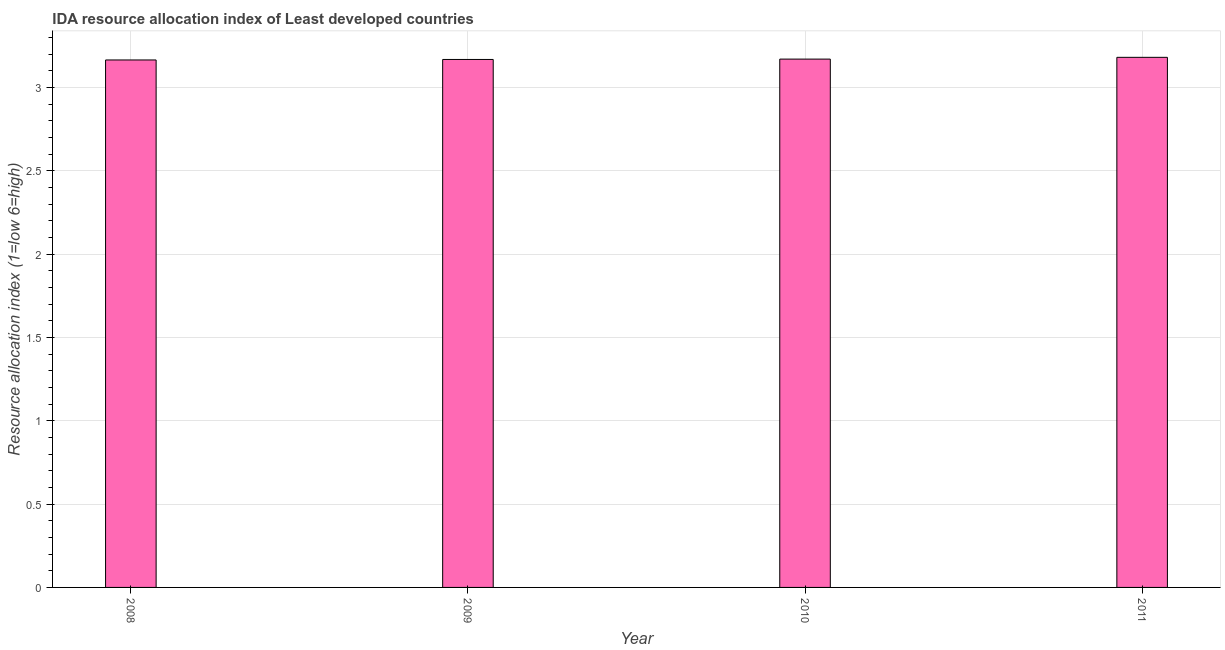What is the title of the graph?
Provide a short and direct response. IDA resource allocation index of Least developed countries. What is the label or title of the X-axis?
Give a very brief answer. Year. What is the label or title of the Y-axis?
Provide a short and direct response. Resource allocation index (1=low 6=high). What is the ida resource allocation index in 2009?
Your answer should be very brief. 3.17. Across all years, what is the maximum ida resource allocation index?
Your answer should be very brief. 3.18. Across all years, what is the minimum ida resource allocation index?
Your answer should be compact. 3.16. In which year was the ida resource allocation index maximum?
Make the answer very short. 2011. In which year was the ida resource allocation index minimum?
Give a very brief answer. 2008. What is the sum of the ida resource allocation index?
Offer a terse response. 12.68. What is the difference between the ida resource allocation index in 2008 and 2010?
Your response must be concise. -0.01. What is the average ida resource allocation index per year?
Provide a succinct answer. 3.17. What is the median ida resource allocation index?
Provide a short and direct response. 3.17. Do a majority of the years between 2008 and 2009 (inclusive) have ida resource allocation index greater than 1.6 ?
Offer a very short reply. Yes. What is the ratio of the ida resource allocation index in 2010 to that in 2011?
Your answer should be compact. 1. Is the ida resource allocation index in 2010 less than that in 2011?
Provide a succinct answer. Yes. Is the difference between the ida resource allocation index in 2009 and 2011 greater than the difference between any two years?
Make the answer very short. No. What is the difference between the highest and the second highest ida resource allocation index?
Ensure brevity in your answer.  0.01. Is the sum of the ida resource allocation index in 2009 and 2010 greater than the maximum ida resource allocation index across all years?
Provide a succinct answer. Yes. What is the difference between the highest and the lowest ida resource allocation index?
Your answer should be very brief. 0.02. In how many years, is the ida resource allocation index greater than the average ida resource allocation index taken over all years?
Your answer should be very brief. 1. Are all the bars in the graph horizontal?
Your answer should be very brief. No. What is the difference between two consecutive major ticks on the Y-axis?
Offer a terse response. 0.5. What is the Resource allocation index (1=low 6=high) in 2008?
Keep it short and to the point. 3.16. What is the Resource allocation index (1=low 6=high) in 2009?
Offer a terse response. 3.17. What is the Resource allocation index (1=low 6=high) in 2010?
Provide a short and direct response. 3.17. What is the Resource allocation index (1=low 6=high) of 2011?
Give a very brief answer. 3.18. What is the difference between the Resource allocation index (1=low 6=high) in 2008 and 2009?
Offer a terse response. -0. What is the difference between the Resource allocation index (1=low 6=high) in 2008 and 2010?
Your answer should be very brief. -0.01. What is the difference between the Resource allocation index (1=low 6=high) in 2008 and 2011?
Your answer should be very brief. -0.02. What is the difference between the Resource allocation index (1=low 6=high) in 2009 and 2010?
Give a very brief answer. -0. What is the difference between the Resource allocation index (1=low 6=high) in 2009 and 2011?
Your answer should be compact. -0.01. What is the difference between the Resource allocation index (1=low 6=high) in 2010 and 2011?
Provide a short and direct response. -0.01. What is the ratio of the Resource allocation index (1=low 6=high) in 2008 to that in 2009?
Ensure brevity in your answer.  1. What is the ratio of the Resource allocation index (1=low 6=high) in 2008 to that in 2010?
Keep it short and to the point. 1. What is the ratio of the Resource allocation index (1=low 6=high) in 2008 to that in 2011?
Give a very brief answer. 0.99. What is the ratio of the Resource allocation index (1=low 6=high) in 2009 to that in 2010?
Give a very brief answer. 1. What is the ratio of the Resource allocation index (1=low 6=high) in 2010 to that in 2011?
Your answer should be compact. 1. 